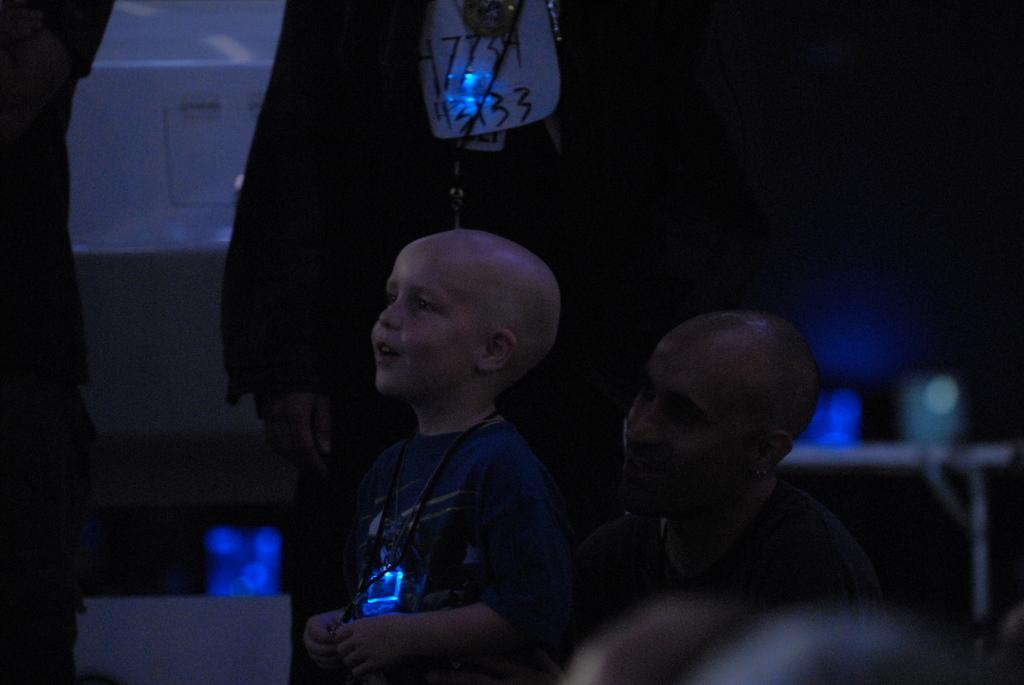Who is the main subject in the image? There is a man in the image. What is the boy doing in front of the man? The boy is standing in front of the man. What is the boy's action or activity in the image? The boy is speaking. Can you describe the people in the background? There are two people standing in the background. How is the background of the image depicted? The background is blurred. What type of frame is the cow standing in front of in the image? There is no cow present in the image, so there is no frame for it to stand in front of. 